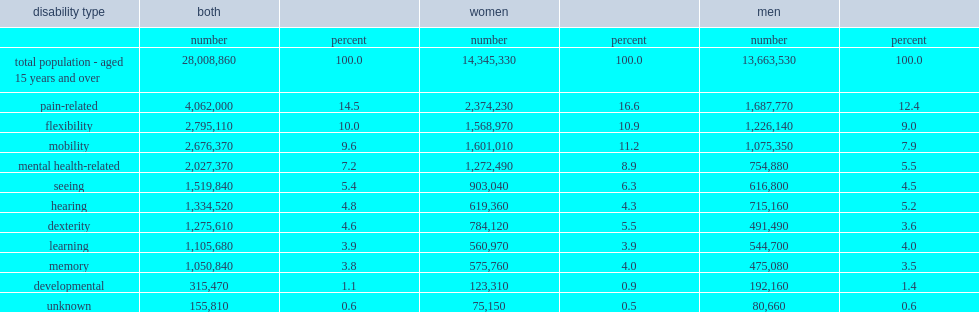List top 4 disability types that were common among canadians aged 15 years and over. Pain-related flexibility mobility mental health-related. What is the least prevalent disability type among canadian aged 15 years and over? Developmental. 